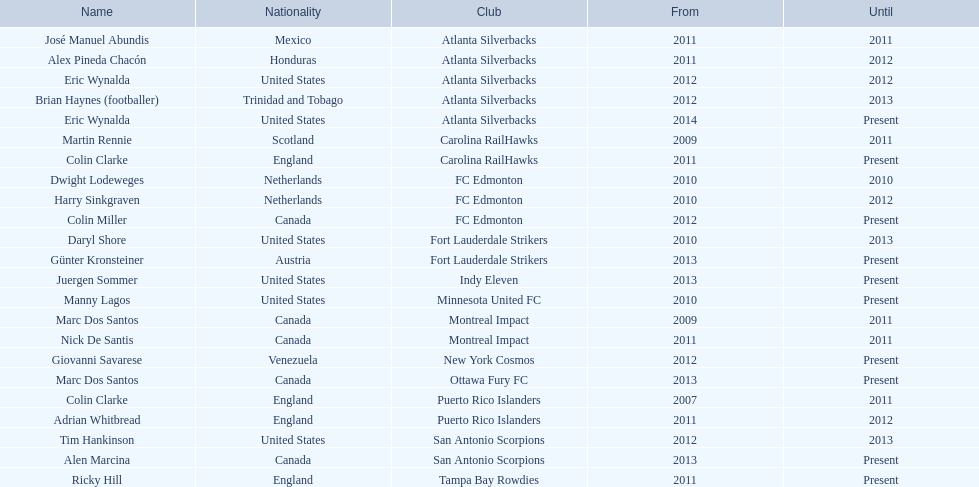In which year did marc dos santos begin his coaching career? 2009. Which other initial years are related to this year? 2009. Who was another coach with the same starting year? Martin Rennie. 